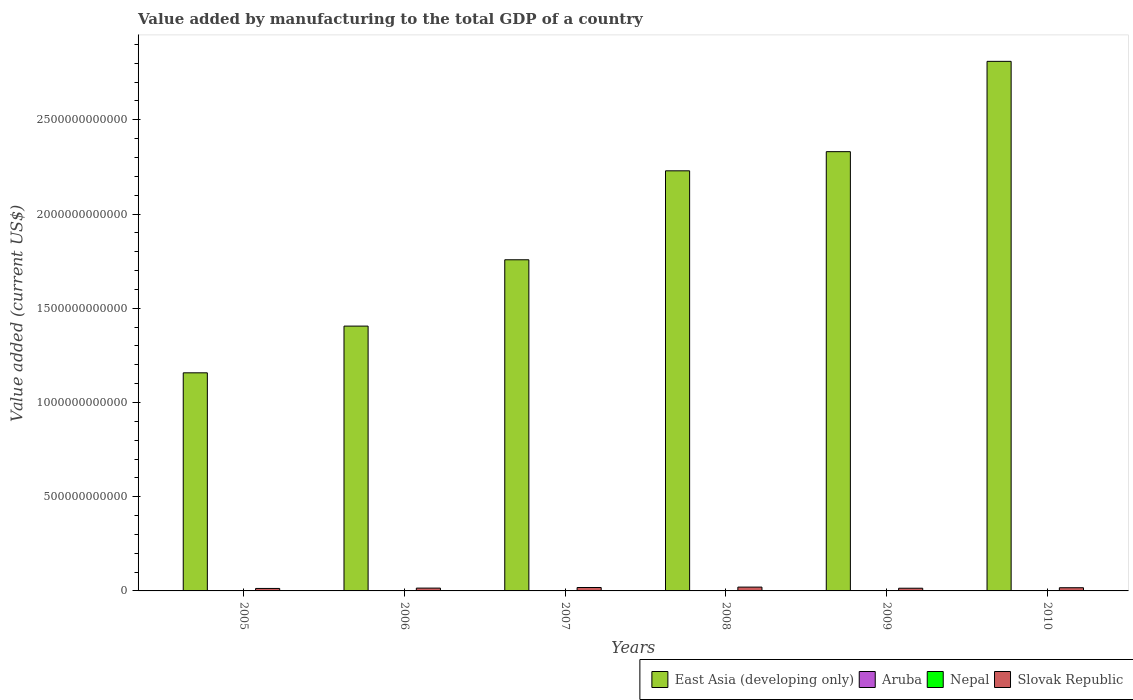How many different coloured bars are there?
Offer a terse response. 4. Are the number of bars per tick equal to the number of legend labels?
Keep it short and to the point. Yes. Are the number of bars on each tick of the X-axis equal?
Ensure brevity in your answer.  Yes. How many bars are there on the 4th tick from the left?
Make the answer very short. 4. What is the label of the 1st group of bars from the left?
Provide a short and direct response. 2005. In how many cases, is the number of bars for a given year not equal to the number of legend labels?
Make the answer very short. 0. What is the value added by manufacturing to the total GDP in Nepal in 2006?
Your answer should be compact. 6.61e+08. Across all years, what is the maximum value added by manufacturing to the total GDP in Aruba?
Keep it short and to the point. 1.02e+08. Across all years, what is the minimum value added by manufacturing to the total GDP in Slovak Republic?
Offer a very short reply. 1.31e+1. In which year was the value added by manufacturing to the total GDP in Aruba maximum?
Provide a short and direct response. 2009. What is the total value added by manufacturing to the total GDP in Nepal in the graph?
Offer a terse response. 4.70e+09. What is the difference between the value added by manufacturing to the total GDP in East Asia (developing only) in 2005 and that in 2006?
Offer a terse response. -2.48e+11. What is the difference between the value added by manufacturing to the total GDP in Aruba in 2005 and the value added by manufacturing to the total GDP in Nepal in 2006?
Keep it short and to the point. -5.75e+08. What is the average value added by manufacturing to the total GDP in Nepal per year?
Keep it short and to the point. 7.84e+08. In the year 2008, what is the difference between the value added by manufacturing to the total GDP in Aruba and value added by manufacturing to the total GDP in Nepal?
Provide a short and direct response. -7.78e+08. What is the ratio of the value added by manufacturing to the total GDP in Nepal in 2005 to that in 2010?
Provide a succinct answer. 0.65. Is the value added by manufacturing to the total GDP in Slovak Republic in 2007 less than that in 2010?
Provide a succinct answer. No. What is the difference between the highest and the second highest value added by manufacturing to the total GDP in Aruba?
Your answer should be compact. 3.30e+05. What is the difference between the highest and the lowest value added by manufacturing to the total GDP in East Asia (developing only)?
Give a very brief answer. 1.65e+12. Is the sum of the value added by manufacturing to the total GDP in East Asia (developing only) in 2009 and 2010 greater than the maximum value added by manufacturing to the total GDP in Slovak Republic across all years?
Offer a terse response. Yes. What does the 3rd bar from the left in 2008 represents?
Your answer should be very brief. Nepal. What does the 3rd bar from the right in 2010 represents?
Keep it short and to the point. Aruba. Is it the case that in every year, the sum of the value added by manufacturing to the total GDP in Slovak Republic and value added by manufacturing to the total GDP in East Asia (developing only) is greater than the value added by manufacturing to the total GDP in Nepal?
Your response must be concise. Yes. What is the difference between two consecutive major ticks on the Y-axis?
Make the answer very short. 5.00e+11. Are the values on the major ticks of Y-axis written in scientific E-notation?
Ensure brevity in your answer.  No. Does the graph contain grids?
Your answer should be very brief. No. Where does the legend appear in the graph?
Offer a very short reply. Bottom right. How are the legend labels stacked?
Provide a succinct answer. Horizontal. What is the title of the graph?
Your response must be concise. Value added by manufacturing to the total GDP of a country. Does "Nigeria" appear as one of the legend labels in the graph?
Provide a short and direct response. No. What is the label or title of the Y-axis?
Your response must be concise. Value added (current US$). What is the Value added (current US$) of East Asia (developing only) in 2005?
Your answer should be very brief. 1.16e+12. What is the Value added (current US$) of Aruba in 2005?
Provide a succinct answer. 8.62e+07. What is the Value added (current US$) of Nepal in 2005?
Ensure brevity in your answer.  6.19e+08. What is the Value added (current US$) in Slovak Republic in 2005?
Give a very brief answer. 1.31e+1. What is the Value added (current US$) in East Asia (developing only) in 2006?
Provide a succinct answer. 1.41e+12. What is the Value added (current US$) in Aruba in 2006?
Your response must be concise. 9.12e+07. What is the Value added (current US$) in Nepal in 2006?
Offer a very short reply. 6.61e+08. What is the Value added (current US$) in Slovak Republic in 2006?
Give a very brief answer. 1.49e+1. What is the Value added (current US$) of East Asia (developing only) in 2007?
Provide a short and direct response. 1.76e+12. What is the Value added (current US$) of Aruba in 2007?
Offer a terse response. 1.01e+08. What is the Value added (current US$) of Nepal in 2007?
Your answer should be very brief. 7.40e+08. What is the Value added (current US$) in Slovak Republic in 2007?
Ensure brevity in your answer.  1.81e+1. What is the Value added (current US$) in East Asia (developing only) in 2008?
Your response must be concise. 2.23e+12. What is the Value added (current US$) in Aruba in 2008?
Keep it short and to the point. 1.02e+08. What is the Value added (current US$) of Nepal in 2008?
Offer a very short reply. 8.80e+08. What is the Value added (current US$) of Slovak Republic in 2008?
Offer a terse response. 2.03e+1. What is the Value added (current US$) in East Asia (developing only) in 2009?
Provide a short and direct response. 2.33e+12. What is the Value added (current US$) of Aruba in 2009?
Keep it short and to the point. 1.02e+08. What is the Value added (current US$) in Nepal in 2009?
Make the answer very short. 8.51e+08. What is the Value added (current US$) of Slovak Republic in 2009?
Offer a very short reply. 1.43e+1. What is the Value added (current US$) of East Asia (developing only) in 2010?
Keep it short and to the point. 2.81e+12. What is the Value added (current US$) in Aruba in 2010?
Give a very brief answer. 1.01e+08. What is the Value added (current US$) of Nepal in 2010?
Keep it short and to the point. 9.52e+08. What is the Value added (current US$) of Slovak Republic in 2010?
Give a very brief answer. 1.69e+1. Across all years, what is the maximum Value added (current US$) in East Asia (developing only)?
Your answer should be compact. 2.81e+12. Across all years, what is the maximum Value added (current US$) of Aruba?
Your answer should be very brief. 1.02e+08. Across all years, what is the maximum Value added (current US$) in Nepal?
Provide a succinct answer. 9.52e+08. Across all years, what is the maximum Value added (current US$) in Slovak Republic?
Your answer should be compact. 2.03e+1. Across all years, what is the minimum Value added (current US$) in East Asia (developing only)?
Provide a succinct answer. 1.16e+12. Across all years, what is the minimum Value added (current US$) of Aruba?
Provide a short and direct response. 8.62e+07. Across all years, what is the minimum Value added (current US$) of Nepal?
Your answer should be very brief. 6.19e+08. Across all years, what is the minimum Value added (current US$) in Slovak Republic?
Offer a terse response. 1.31e+1. What is the total Value added (current US$) of East Asia (developing only) in the graph?
Make the answer very short. 1.17e+13. What is the total Value added (current US$) of Aruba in the graph?
Provide a succinct answer. 5.84e+08. What is the total Value added (current US$) of Nepal in the graph?
Give a very brief answer. 4.70e+09. What is the total Value added (current US$) of Slovak Republic in the graph?
Your response must be concise. 9.76e+1. What is the difference between the Value added (current US$) in East Asia (developing only) in 2005 and that in 2006?
Provide a short and direct response. -2.48e+11. What is the difference between the Value added (current US$) in Aruba in 2005 and that in 2006?
Your answer should be very brief. -4.98e+06. What is the difference between the Value added (current US$) of Nepal in 2005 and that in 2006?
Offer a very short reply. -4.23e+07. What is the difference between the Value added (current US$) of Slovak Republic in 2005 and that in 2006?
Offer a terse response. -1.83e+09. What is the difference between the Value added (current US$) of East Asia (developing only) in 2005 and that in 2007?
Make the answer very short. -6.00e+11. What is the difference between the Value added (current US$) in Aruba in 2005 and that in 2007?
Provide a short and direct response. -1.46e+07. What is the difference between the Value added (current US$) in Nepal in 2005 and that in 2007?
Your response must be concise. -1.21e+08. What is the difference between the Value added (current US$) in Slovak Republic in 2005 and that in 2007?
Your answer should be very brief. -5.00e+09. What is the difference between the Value added (current US$) in East Asia (developing only) in 2005 and that in 2008?
Offer a very short reply. -1.07e+12. What is the difference between the Value added (current US$) of Aruba in 2005 and that in 2008?
Provide a succinct answer. -1.57e+07. What is the difference between the Value added (current US$) of Nepal in 2005 and that in 2008?
Give a very brief answer. -2.60e+08. What is the difference between the Value added (current US$) in Slovak Republic in 2005 and that in 2008?
Give a very brief answer. -7.15e+09. What is the difference between the Value added (current US$) of East Asia (developing only) in 2005 and that in 2009?
Make the answer very short. -1.17e+12. What is the difference between the Value added (current US$) of Aruba in 2005 and that in 2009?
Give a very brief answer. -1.60e+07. What is the difference between the Value added (current US$) in Nepal in 2005 and that in 2009?
Make the answer very short. -2.32e+08. What is the difference between the Value added (current US$) in Slovak Republic in 2005 and that in 2009?
Ensure brevity in your answer.  -1.19e+09. What is the difference between the Value added (current US$) in East Asia (developing only) in 2005 and that in 2010?
Ensure brevity in your answer.  -1.65e+12. What is the difference between the Value added (current US$) of Aruba in 2005 and that in 2010?
Offer a terse response. -1.50e+07. What is the difference between the Value added (current US$) of Nepal in 2005 and that in 2010?
Keep it short and to the point. -3.32e+08. What is the difference between the Value added (current US$) of Slovak Republic in 2005 and that in 2010?
Your answer should be compact. -3.81e+09. What is the difference between the Value added (current US$) in East Asia (developing only) in 2006 and that in 2007?
Offer a very short reply. -3.52e+11. What is the difference between the Value added (current US$) of Aruba in 2006 and that in 2007?
Offer a terse response. -9.60e+06. What is the difference between the Value added (current US$) in Nepal in 2006 and that in 2007?
Make the answer very short. -7.87e+07. What is the difference between the Value added (current US$) of Slovak Republic in 2006 and that in 2007?
Offer a terse response. -3.17e+09. What is the difference between the Value added (current US$) in East Asia (developing only) in 2006 and that in 2008?
Your answer should be compact. -8.24e+11. What is the difference between the Value added (current US$) of Aruba in 2006 and that in 2008?
Your answer should be compact. -1.07e+07. What is the difference between the Value added (current US$) of Nepal in 2006 and that in 2008?
Offer a very short reply. -2.18e+08. What is the difference between the Value added (current US$) in Slovak Republic in 2006 and that in 2008?
Provide a short and direct response. -5.32e+09. What is the difference between the Value added (current US$) of East Asia (developing only) in 2006 and that in 2009?
Offer a terse response. -9.26e+11. What is the difference between the Value added (current US$) in Aruba in 2006 and that in 2009?
Make the answer very short. -1.10e+07. What is the difference between the Value added (current US$) in Nepal in 2006 and that in 2009?
Provide a short and direct response. -1.90e+08. What is the difference between the Value added (current US$) of Slovak Republic in 2006 and that in 2009?
Ensure brevity in your answer.  6.43e+08. What is the difference between the Value added (current US$) in East Asia (developing only) in 2006 and that in 2010?
Give a very brief answer. -1.40e+12. What is the difference between the Value added (current US$) in Aruba in 2006 and that in 2010?
Keep it short and to the point. -1.00e+07. What is the difference between the Value added (current US$) of Nepal in 2006 and that in 2010?
Keep it short and to the point. -2.90e+08. What is the difference between the Value added (current US$) in Slovak Republic in 2006 and that in 2010?
Make the answer very short. -1.97e+09. What is the difference between the Value added (current US$) of East Asia (developing only) in 2007 and that in 2008?
Offer a terse response. -4.72e+11. What is the difference between the Value added (current US$) of Aruba in 2007 and that in 2008?
Offer a terse response. -1.11e+06. What is the difference between the Value added (current US$) in Nepal in 2007 and that in 2008?
Your response must be concise. -1.39e+08. What is the difference between the Value added (current US$) of Slovak Republic in 2007 and that in 2008?
Your answer should be compact. -2.14e+09. What is the difference between the Value added (current US$) of East Asia (developing only) in 2007 and that in 2009?
Give a very brief answer. -5.74e+11. What is the difference between the Value added (current US$) in Aruba in 2007 and that in 2009?
Offer a very short reply. -1.44e+06. What is the difference between the Value added (current US$) in Nepal in 2007 and that in 2009?
Your response must be concise. -1.11e+08. What is the difference between the Value added (current US$) of Slovak Republic in 2007 and that in 2009?
Give a very brief answer. 3.81e+09. What is the difference between the Value added (current US$) in East Asia (developing only) in 2007 and that in 2010?
Ensure brevity in your answer.  -1.05e+12. What is the difference between the Value added (current US$) of Aruba in 2007 and that in 2010?
Your answer should be compact. -4.08e+05. What is the difference between the Value added (current US$) in Nepal in 2007 and that in 2010?
Provide a succinct answer. -2.11e+08. What is the difference between the Value added (current US$) of Slovak Republic in 2007 and that in 2010?
Make the answer very short. 1.20e+09. What is the difference between the Value added (current US$) of East Asia (developing only) in 2008 and that in 2009?
Offer a terse response. -1.02e+11. What is the difference between the Value added (current US$) in Aruba in 2008 and that in 2009?
Provide a short and direct response. -3.30e+05. What is the difference between the Value added (current US$) of Nepal in 2008 and that in 2009?
Provide a short and direct response. 2.82e+07. What is the difference between the Value added (current US$) of Slovak Republic in 2008 and that in 2009?
Give a very brief answer. 5.96e+09. What is the difference between the Value added (current US$) of East Asia (developing only) in 2008 and that in 2010?
Your response must be concise. -5.81e+11. What is the difference between the Value added (current US$) in Aruba in 2008 and that in 2010?
Offer a very short reply. 7.04e+05. What is the difference between the Value added (current US$) of Nepal in 2008 and that in 2010?
Provide a succinct answer. -7.20e+07. What is the difference between the Value added (current US$) in Slovak Republic in 2008 and that in 2010?
Keep it short and to the point. 3.34e+09. What is the difference between the Value added (current US$) in East Asia (developing only) in 2009 and that in 2010?
Provide a short and direct response. -4.79e+11. What is the difference between the Value added (current US$) in Aruba in 2009 and that in 2010?
Ensure brevity in your answer.  1.03e+06. What is the difference between the Value added (current US$) in Nepal in 2009 and that in 2010?
Offer a terse response. -1.00e+08. What is the difference between the Value added (current US$) in Slovak Republic in 2009 and that in 2010?
Provide a succinct answer. -2.62e+09. What is the difference between the Value added (current US$) in East Asia (developing only) in 2005 and the Value added (current US$) in Aruba in 2006?
Your answer should be very brief. 1.16e+12. What is the difference between the Value added (current US$) in East Asia (developing only) in 2005 and the Value added (current US$) in Nepal in 2006?
Provide a short and direct response. 1.16e+12. What is the difference between the Value added (current US$) of East Asia (developing only) in 2005 and the Value added (current US$) of Slovak Republic in 2006?
Offer a terse response. 1.14e+12. What is the difference between the Value added (current US$) in Aruba in 2005 and the Value added (current US$) in Nepal in 2006?
Ensure brevity in your answer.  -5.75e+08. What is the difference between the Value added (current US$) of Aruba in 2005 and the Value added (current US$) of Slovak Republic in 2006?
Offer a very short reply. -1.49e+1. What is the difference between the Value added (current US$) of Nepal in 2005 and the Value added (current US$) of Slovak Republic in 2006?
Give a very brief answer. -1.43e+1. What is the difference between the Value added (current US$) of East Asia (developing only) in 2005 and the Value added (current US$) of Aruba in 2007?
Make the answer very short. 1.16e+12. What is the difference between the Value added (current US$) in East Asia (developing only) in 2005 and the Value added (current US$) in Nepal in 2007?
Your answer should be very brief. 1.16e+12. What is the difference between the Value added (current US$) in East Asia (developing only) in 2005 and the Value added (current US$) in Slovak Republic in 2007?
Your answer should be compact. 1.14e+12. What is the difference between the Value added (current US$) in Aruba in 2005 and the Value added (current US$) in Nepal in 2007?
Ensure brevity in your answer.  -6.54e+08. What is the difference between the Value added (current US$) of Aruba in 2005 and the Value added (current US$) of Slovak Republic in 2007?
Offer a terse response. -1.80e+1. What is the difference between the Value added (current US$) of Nepal in 2005 and the Value added (current US$) of Slovak Republic in 2007?
Make the answer very short. -1.75e+1. What is the difference between the Value added (current US$) in East Asia (developing only) in 2005 and the Value added (current US$) in Aruba in 2008?
Offer a very short reply. 1.16e+12. What is the difference between the Value added (current US$) of East Asia (developing only) in 2005 and the Value added (current US$) of Nepal in 2008?
Your answer should be compact. 1.16e+12. What is the difference between the Value added (current US$) in East Asia (developing only) in 2005 and the Value added (current US$) in Slovak Republic in 2008?
Make the answer very short. 1.14e+12. What is the difference between the Value added (current US$) of Aruba in 2005 and the Value added (current US$) of Nepal in 2008?
Ensure brevity in your answer.  -7.93e+08. What is the difference between the Value added (current US$) in Aruba in 2005 and the Value added (current US$) in Slovak Republic in 2008?
Your response must be concise. -2.02e+1. What is the difference between the Value added (current US$) in Nepal in 2005 and the Value added (current US$) in Slovak Republic in 2008?
Give a very brief answer. -1.96e+1. What is the difference between the Value added (current US$) in East Asia (developing only) in 2005 and the Value added (current US$) in Aruba in 2009?
Your answer should be very brief. 1.16e+12. What is the difference between the Value added (current US$) of East Asia (developing only) in 2005 and the Value added (current US$) of Nepal in 2009?
Keep it short and to the point. 1.16e+12. What is the difference between the Value added (current US$) in East Asia (developing only) in 2005 and the Value added (current US$) in Slovak Republic in 2009?
Your response must be concise. 1.14e+12. What is the difference between the Value added (current US$) in Aruba in 2005 and the Value added (current US$) in Nepal in 2009?
Provide a short and direct response. -7.65e+08. What is the difference between the Value added (current US$) of Aruba in 2005 and the Value added (current US$) of Slovak Republic in 2009?
Provide a short and direct response. -1.42e+1. What is the difference between the Value added (current US$) of Nepal in 2005 and the Value added (current US$) of Slovak Republic in 2009?
Give a very brief answer. -1.37e+1. What is the difference between the Value added (current US$) of East Asia (developing only) in 2005 and the Value added (current US$) of Aruba in 2010?
Offer a terse response. 1.16e+12. What is the difference between the Value added (current US$) of East Asia (developing only) in 2005 and the Value added (current US$) of Nepal in 2010?
Offer a very short reply. 1.16e+12. What is the difference between the Value added (current US$) in East Asia (developing only) in 2005 and the Value added (current US$) in Slovak Republic in 2010?
Give a very brief answer. 1.14e+12. What is the difference between the Value added (current US$) in Aruba in 2005 and the Value added (current US$) in Nepal in 2010?
Your answer should be very brief. -8.65e+08. What is the difference between the Value added (current US$) in Aruba in 2005 and the Value added (current US$) in Slovak Republic in 2010?
Make the answer very short. -1.68e+1. What is the difference between the Value added (current US$) of Nepal in 2005 and the Value added (current US$) of Slovak Republic in 2010?
Your answer should be compact. -1.63e+1. What is the difference between the Value added (current US$) in East Asia (developing only) in 2006 and the Value added (current US$) in Aruba in 2007?
Provide a short and direct response. 1.41e+12. What is the difference between the Value added (current US$) in East Asia (developing only) in 2006 and the Value added (current US$) in Nepal in 2007?
Your response must be concise. 1.40e+12. What is the difference between the Value added (current US$) in East Asia (developing only) in 2006 and the Value added (current US$) in Slovak Republic in 2007?
Your answer should be compact. 1.39e+12. What is the difference between the Value added (current US$) of Aruba in 2006 and the Value added (current US$) of Nepal in 2007?
Make the answer very short. -6.49e+08. What is the difference between the Value added (current US$) in Aruba in 2006 and the Value added (current US$) in Slovak Republic in 2007?
Offer a very short reply. -1.80e+1. What is the difference between the Value added (current US$) of Nepal in 2006 and the Value added (current US$) of Slovak Republic in 2007?
Ensure brevity in your answer.  -1.74e+1. What is the difference between the Value added (current US$) of East Asia (developing only) in 2006 and the Value added (current US$) of Aruba in 2008?
Give a very brief answer. 1.41e+12. What is the difference between the Value added (current US$) of East Asia (developing only) in 2006 and the Value added (current US$) of Nepal in 2008?
Make the answer very short. 1.40e+12. What is the difference between the Value added (current US$) of East Asia (developing only) in 2006 and the Value added (current US$) of Slovak Republic in 2008?
Keep it short and to the point. 1.39e+12. What is the difference between the Value added (current US$) in Aruba in 2006 and the Value added (current US$) in Nepal in 2008?
Provide a succinct answer. -7.88e+08. What is the difference between the Value added (current US$) of Aruba in 2006 and the Value added (current US$) of Slovak Republic in 2008?
Make the answer very short. -2.02e+1. What is the difference between the Value added (current US$) in Nepal in 2006 and the Value added (current US$) in Slovak Republic in 2008?
Provide a succinct answer. -1.96e+1. What is the difference between the Value added (current US$) of East Asia (developing only) in 2006 and the Value added (current US$) of Aruba in 2009?
Give a very brief answer. 1.41e+12. What is the difference between the Value added (current US$) of East Asia (developing only) in 2006 and the Value added (current US$) of Nepal in 2009?
Your answer should be compact. 1.40e+12. What is the difference between the Value added (current US$) of East Asia (developing only) in 2006 and the Value added (current US$) of Slovak Republic in 2009?
Provide a short and direct response. 1.39e+12. What is the difference between the Value added (current US$) in Aruba in 2006 and the Value added (current US$) in Nepal in 2009?
Keep it short and to the point. -7.60e+08. What is the difference between the Value added (current US$) of Aruba in 2006 and the Value added (current US$) of Slovak Republic in 2009?
Your response must be concise. -1.42e+1. What is the difference between the Value added (current US$) in Nepal in 2006 and the Value added (current US$) in Slovak Republic in 2009?
Your answer should be compact. -1.36e+1. What is the difference between the Value added (current US$) in East Asia (developing only) in 2006 and the Value added (current US$) in Aruba in 2010?
Your answer should be very brief. 1.41e+12. What is the difference between the Value added (current US$) of East Asia (developing only) in 2006 and the Value added (current US$) of Nepal in 2010?
Your response must be concise. 1.40e+12. What is the difference between the Value added (current US$) in East Asia (developing only) in 2006 and the Value added (current US$) in Slovak Republic in 2010?
Your response must be concise. 1.39e+12. What is the difference between the Value added (current US$) of Aruba in 2006 and the Value added (current US$) of Nepal in 2010?
Offer a terse response. -8.60e+08. What is the difference between the Value added (current US$) in Aruba in 2006 and the Value added (current US$) in Slovak Republic in 2010?
Your answer should be very brief. -1.68e+1. What is the difference between the Value added (current US$) of Nepal in 2006 and the Value added (current US$) of Slovak Republic in 2010?
Provide a succinct answer. -1.63e+1. What is the difference between the Value added (current US$) in East Asia (developing only) in 2007 and the Value added (current US$) in Aruba in 2008?
Your response must be concise. 1.76e+12. What is the difference between the Value added (current US$) in East Asia (developing only) in 2007 and the Value added (current US$) in Nepal in 2008?
Make the answer very short. 1.76e+12. What is the difference between the Value added (current US$) of East Asia (developing only) in 2007 and the Value added (current US$) of Slovak Republic in 2008?
Your answer should be compact. 1.74e+12. What is the difference between the Value added (current US$) of Aruba in 2007 and the Value added (current US$) of Nepal in 2008?
Provide a short and direct response. -7.79e+08. What is the difference between the Value added (current US$) of Aruba in 2007 and the Value added (current US$) of Slovak Republic in 2008?
Your answer should be compact. -2.02e+1. What is the difference between the Value added (current US$) in Nepal in 2007 and the Value added (current US$) in Slovak Republic in 2008?
Offer a very short reply. -1.95e+1. What is the difference between the Value added (current US$) of East Asia (developing only) in 2007 and the Value added (current US$) of Aruba in 2009?
Provide a short and direct response. 1.76e+12. What is the difference between the Value added (current US$) in East Asia (developing only) in 2007 and the Value added (current US$) in Nepal in 2009?
Your answer should be compact. 1.76e+12. What is the difference between the Value added (current US$) in East Asia (developing only) in 2007 and the Value added (current US$) in Slovak Republic in 2009?
Offer a terse response. 1.74e+12. What is the difference between the Value added (current US$) in Aruba in 2007 and the Value added (current US$) in Nepal in 2009?
Provide a succinct answer. -7.51e+08. What is the difference between the Value added (current US$) in Aruba in 2007 and the Value added (current US$) in Slovak Republic in 2009?
Offer a terse response. -1.42e+1. What is the difference between the Value added (current US$) in Nepal in 2007 and the Value added (current US$) in Slovak Republic in 2009?
Your answer should be very brief. -1.36e+1. What is the difference between the Value added (current US$) in East Asia (developing only) in 2007 and the Value added (current US$) in Aruba in 2010?
Offer a terse response. 1.76e+12. What is the difference between the Value added (current US$) in East Asia (developing only) in 2007 and the Value added (current US$) in Nepal in 2010?
Provide a short and direct response. 1.76e+12. What is the difference between the Value added (current US$) of East Asia (developing only) in 2007 and the Value added (current US$) of Slovak Republic in 2010?
Your answer should be very brief. 1.74e+12. What is the difference between the Value added (current US$) of Aruba in 2007 and the Value added (current US$) of Nepal in 2010?
Provide a short and direct response. -8.51e+08. What is the difference between the Value added (current US$) of Aruba in 2007 and the Value added (current US$) of Slovak Republic in 2010?
Give a very brief answer. -1.68e+1. What is the difference between the Value added (current US$) of Nepal in 2007 and the Value added (current US$) of Slovak Republic in 2010?
Give a very brief answer. -1.62e+1. What is the difference between the Value added (current US$) of East Asia (developing only) in 2008 and the Value added (current US$) of Aruba in 2009?
Your answer should be compact. 2.23e+12. What is the difference between the Value added (current US$) in East Asia (developing only) in 2008 and the Value added (current US$) in Nepal in 2009?
Keep it short and to the point. 2.23e+12. What is the difference between the Value added (current US$) of East Asia (developing only) in 2008 and the Value added (current US$) of Slovak Republic in 2009?
Keep it short and to the point. 2.22e+12. What is the difference between the Value added (current US$) in Aruba in 2008 and the Value added (current US$) in Nepal in 2009?
Offer a very short reply. -7.49e+08. What is the difference between the Value added (current US$) of Aruba in 2008 and the Value added (current US$) of Slovak Republic in 2009?
Provide a succinct answer. -1.42e+1. What is the difference between the Value added (current US$) in Nepal in 2008 and the Value added (current US$) in Slovak Republic in 2009?
Offer a very short reply. -1.34e+1. What is the difference between the Value added (current US$) of East Asia (developing only) in 2008 and the Value added (current US$) of Aruba in 2010?
Keep it short and to the point. 2.23e+12. What is the difference between the Value added (current US$) in East Asia (developing only) in 2008 and the Value added (current US$) in Nepal in 2010?
Your answer should be very brief. 2.23e+12. What is the difference between the Value added (current US$) of East Asia (developing only) in 2008 and the Value added (current US$) of Slovak Republic in 2010?
Make the answer very short. 2.21e+12. What is the difference between the Value added (current US$) of Aruba in 2008 and the Value added (current US$) of Nepal in 2010?
Your response must be concise. -8.50e+08. What is the difference between the Value added (current US$) of Aruba in 2008 and the Value added (current US$) of Slovak Republic in 2010?
Your answer should be very brief. -1.68e+1. What is the difference between the Value added (current US$) of Nepal in 2008 and the Value added (current US$) of Slovak Republic in 2010?
Your answer should be compact. -1.60e+1. What is the difference between the Value added (current US$) of East Asia (developing only) in 2009 and the Value added (current US$) of Aruba in 2010?
Provide a succinct answer. 2.33e+12. What is the difference between the Value added (current US$) in East Asia (developing only) in 2009 and the Value added (current US$) in Nepal in 2010?
Ensure brevity in your answer.  2.33e+12. What is the difference between the Value added (current US$) in East Asia (developing only) in 2009 and the Value added (current US$) in Slovak Republic in 2010?
Offer a very short reply. 2.31e+12. What is the difference between the Value added (current US$) of Aruba in 2009 and the Value added (current US$) of Nepal in 2010?
Give a very brief answer. -8.49e+08. What is the difference between the Value added (current US$) of Aruba in 2009 and the Value added (current US$) of Slovak Republic in 2010?
Provide a succinct answer. -1.68e+1. What is the difference between the Value added (current US$) of Nepal in 2009 and the Value added (current US$) of Slovak Republic in 2010?
Provide a succinct answer. -1.61e+1. What is the average Value added (current US$) of East Asia (developing only) per year?
Ensure brevity in your answer.  1.95e+12. What is the average Value added (current US$) in Aruba per year?
Provide a short and direct response. 9.73e+07. What is the average Value added (current US$) of Nepal per year?
Provide a short and direct response. 7.84e+08. What is the average Value added (current US$) of Slovak Republic per year?
Your response must be concise. 1.63e+1. In the year 2005, what is the difference between the Value added (current US$) in East Asia (developing only) and Value added (current US$) in Aruba?
Ensure brevity in your answer.  1.16e+12. In the year 2005, what is the difference between the Value added (current US$) in East Asia (developing only) and Value added (current US$) in Nepal?
Provide a short and direct response. 1.16e+12. In the year 2005, what is the difference between the Value added (current US$) in East Asia (developing only) and Value added (current US$) in Slovak Republic?
Offer a terse response. 1.14e+12. In the year 2005, what is the difference between the Value added (current US$) of Aruba and Value added (current US$) of Nepal?
Provide a succinct answer. -5.33e+08. In the year 2005, what is the difference between the Value added (current US$) of Aruba and Value added (current US$) of Slovak Republic?
Ensure brevity in your answer.  -1.30e+1. In the year 2005, what is the difference between the Value added (current US$) of Nepal and Value added (current US$) of Slovak Republic?
Make the answer very short. -1.25e+1. In the year 2006, what is the difference between the Value added (current US$) in East Asia (developing only) and Value added (current US$) in Aruba?
Ensure brevity in your answer.  1.41e+12. In the year 2006, what is the difference between the Value added (current US$) of East Asia (developing only) and Value added (current US$) of Nepal?
Ensure brevity in your answer.  1.40e+12. In the year 2006, what is the difference between the Value added (current US$) in East Asia (developing only) and Value added (current US$) in Slovak Republic?
Give a very brief answer. 1.39e+12. In the year 2006, what is the difference between the Value added (current US$) in Aruba and Value added (current US$) in Nepal?
Keep it short and to the point. -5.70e+08. In the year 2006, what is the difference between the Value added (current US$) of Aruba and Value added (current US$) of Slovak Republic?
Offer a terse response. -1.48e+1. In the year 2006, what is the difference between the Value added (current US$) of Nepal and Value added (current US$) of Slovak Republic?
Offer a terse response. -1.43e+1. In the year 2007, what is the difference between the Value added (current US$) in East Asia (developing only) and Value added (current US$) in Aruba?
Your answer should be compact. 1.76e+12. In the year 2007, what is the difference between the Value added (current US$) of East Asia (developing only) and Value added (current US$) of Nepal?
Make the answer very short. 1.76e+12. In the year 2007, what is the difference between the Value added (current US$) in East Asia (developing only) and Value added (current US$) in Slovak Republic?
Provide a succinct answer. 1.74e+12. In the year 2007, what is the difference between the Value added (current US$) in Aruba and Value added (current US$) in Nepal?
Give a very brief answer. -6.39e+08. In the year 2007, what is the difference between the Value added (current US$) in Aruba and Value added (current US$) in Slovak Republic?
Provide a short and direct response. -1.80e+1. In the year 2007, what is the difference between the Value added (current US$) of Nepal and Value added (current US$) of Slovak Republic?
Provide a short and direct response. -1.74e+1. In the year 2008, what is the difference between the Value added (current US$) of East Asia (developing only) and Value added (current US$) of Aruba?
Your answer should be very brief. 2.23e+12. In the year 2008, what is the difference between the Value added (current US$) in East Asia (developing only) and Value added (current US$) in Nepal?
Offer a very short reply. 2.23e+12. In the year 2008, what is the difference between the Value added (current US$) of East Asia (developing only) and Value added (current US$) of Slovak Republic?
Offer a terse response. 2.21e+12. In the year 2008, what is the difference between the Value added (current US$) of Aruba and Value added (current US$) of Nepal?
Make the answer very short. -7.78e+08. In the year 2008, what is the difference between the Value added (current US$) of Aruba and Value added (current US$) of Slovak Republic?
Your answer should be compact. -2.02e+1. In the year 2008, what is the difference between the Value added (current US$) of Nepal and Value added (current US$) of Slovak Republic?
Give a very brief answer. -1.94e+1. In the year 2009, what is the difference between the Value added (current US$) in East Asia (developing only) and Value added (current US$) in Aruba?
Keep it short and to the point. 2.33e+12. In the year 2009, what is the difference between the Value added (current US$) in East Asia (developing only) and Value added (current US$) in Nepal?
Your answer should be compact. 2.33e+12. In the year 2009, what is the difference between the Value added (current US$) in East Asia (developing only) and Value added (current US$) in Slovak Republic?
Keep it short and to the point. 2.32e+12. In the year 2009, what is the difference between the Value added (current US$) of Aruba and Value added (current US$) of Nepal?
Make the answer very short. -7.49e+08. In the year 2009, what is the difference between the Value added (current US$) in Aruba and Value added (current US$) in Slovak Republic?
Provide a short and direct response. -1.42e+1. In the year 2009, what is the difference between the Value added (current US$) in Nepal and Value added (current US$) in Slovak Republic?
Your response must be concise. -1.34e+1. In the year 2010, what is the difference between the Value added (current US$) in East Asia (developing only) and Value added (current US$) in Aruba?
Your answer should be compact. 2.81e+12. In the year 2010, what is the difference between the Value added (current US$) of East Asia (developing only) and Value added (current US$) of Nepal?
Provide a short and direct response. 2.81e+12. In the year 2010, what is the difference between the Value added (current US$) in East Asia (developing only) and Value added (current US$) in Slovak Republic?
Your response must be concise. 2.79e+12. In the year 2010, what is the difference between the Value added (current US$) in Aruba and Value added (current US$) in Nepal?
Give a very brief answer. -8.50e+08. In the year 2010, what is the difference between the Value added (current US$) in Aruba and Value added (current US$) in Slovak Republic?
Your response must be concise. -1.68e+1. In the year 2010, what is the difference between the Value added (current US$) of Nepal and Value added (current US$) of Slovak Republic?
Provide a short and direct response. -1.60e+1. What is the ratio of the Value added (current US$) in East Asia (developing only) in 2005 to that in 2006?
Your answer should be very brief. 0.82. What is the ratio of the Value added (current US$) in Aruba in 2005 to that in 2006?
Make the answer very short. 0.95. What is the ratio of the Value added (current US$) in Nepal in 2005 to that in 2006?
Make the answer very short. 0.94. What is the ratio of the Value added (current US$) in Slovak Republic in 2005 to that in 2006?
Make the answer very short. 0.88. What is the ratio of the Value added (current US$) of East Asia (developing only) in 2005 to that in 2007?
Your response must be concise. 0.66. What is the ratio of the Value added (current US$) in Aruba in 2005 to that in 2007?
Offer a terse response. 0.86. What is the ratio of the Value added (current US$) of Nepal in 2005 to that in 2007?
Provide a short and direct response. 0.84. What is the ratio of the Value added (current US$) in Slovak Republic in 2005 to that in 2007?
Your answer should be compact. 0.72. What is the ratio of the Value added (current US$) of East Asia (developing only) in 2005 to that in 2008?
Make the answer very short. 0.52. What is the ratio of the Value added (current US$) of Aruba in 2005 to that in 2008?
Your response must be concise. 0.85. What is the ratio of the Value added (current US$) of Nepal in 2005 to that in 2008?
Keep it short and to the point. 0.7. What is the ratio of the Value added (current US$) of Slovak Republic in 2005 to that in 2008?
Provide a succinct answer. 0.65. What is the ratio of the Value added (current US$) in East Asia (developing only) in 2005 to that in 2009?
Make the answer very short. 0.5. What is the ratio of the Value added (current US$) of Aruba in 2005 to that in 2009?
Keep it short and to the point. 0.84. What is the ratio of the Value added (current US$) in Nepal in 2005 to that in 2009?
Make the answer very short. 0.73. What is the ratio of the Value added (current US$) of Slovak Republic in 2005 to that in 2009?
Your answer should be compact. 0.92. What is the ratio of the Value added (current US$) in East Asia (developing only) in 2005 to that in 2010?
Offer a very short reply. 0.41. What is the ratio of the Value added (current US$) of Aruba in 2005 to that in 2010?
Provide a succinct answer. 0.85. What is the ratio of the Value added (current US$) in Nepal in 2005 to that in 2010?
Your answer should be very brief. 0.65. What is the ratio of the Value added (current US$) of Slovak Republic in 2005 to that in 2010?
Your answer should be very brief. 0.78. What is the ratio of the Value added (current US$) of East Asia (developing only) in 2006 to that in 2007?
Provide a short and direct response. 0.8. What is the ratio of the Value added (current US$) in Aruba in 2006 to that in 2007?
Your answer should be very brief. 0.9. What is the ratio of the Value added (current US$) of Nepal in 2006 to that in 2007?
Your response must be concise. 0.89. What is the ratio of the Value added (current US$) of Slovak Republic in 2006 to that in 2007?
Ensure brevity in your answer.  0.82. What is the ratio of the Value added (current US$) in East Asia (developing only) in 2006 to that in 2008?
Give a very brief answer. 0.63. What is the ratio of the Value added (current US$) in Aruba in 2006 to that in 2008?
Ensure brevity in your answer.  0.89. What is the ratio of the Value added (current US$) in Nepal in 2006 to that in 2008?
Your answer should be compact. 0.75. What is the ratio of the Value added (current US$) of Slovak Republic in 2006 to that in 2008?
Your answer should be compact. 0.74. What is the ratio of the Value added (current US$) in East Asia (developing only) in 2006 to that in 2009?
Offer a very short reply. 0.6. What is the ratio of the Value added (current US$) of Aruba in 2006 to that in 2009?
Offer a very short reply. 0.89. What is the ratio of the Value added (current US$) in Nepal in 2006 to that in 2009?
Give a very brief answer. 0.78. What is the ratio of the Value added (current US$) in Slovak Republic in 2006 to that in 2009?
Provide a short and direct response. 1.04. What is the ratio of the Value added (current US$) of East Asia (developing only) in 2006 to that in 2010?
Make the answer very short. 0.5. What is the ratio of the Value added (current US$) of Aruba in 2006 to that in 2010?
Your response must be concise. 0.9. What is the ratio of the Value added (current US$) of Nepal in 2006 to that in 2010?
Keep it short and to the point. 0.7. What is the ratio of the Value added (current US$) in Slovak Republic in 2006 to that in 2010?
Your answer should be very brief. 0.88. What is the ratio of the Value added (current US$) in East Asia (developing only) in 2007 to that in 2008?
Offer a very short reply. 0.79. What is the ratio of the Value added (current US$) of Aruba in 2007 to that in 2008?
Your answer should be compact. 0.99. What is the ratio of the Value added (current US$) in Nepal in 2007 to that in 2008?
Offer a very short reply. 0.84. What is the ratio of the Value added (current US$) in Slovak Republic in 2007 to that in 2008?
Provide a short and direct response. 0.89. What is the ratio of the Value added (current US$) in East Asia (developing only) in 2007 to that in 2009?
Give a very brief answer. 0.75. What is the ratio of the Value added (current US$) in Aruba in 2007 to that in 2009?
Offer a terse response. 0.99. What is the ratio of the Value added (current US$) of Nepal in 2007 to that in 2009?
Your answer should be compact. 0.87. What is the ratio of the Value added (current US$) of Slovak Republic in 2007 to that in 2009?
Your answer should be very brief. 1.27. What is the ratio of the Value added (current US$) of East Asia (developing only) in 2007 to that in 2010?
Provide a succinct answer. 0.63. What is the ratio of the Value added (current US$) in Aruba in 2007 to that in 2010?
Make the answer very short. 1. What is the ratio of the Value added (current US$) of Nepal in 2007 to that in 2010?
Offer a very short reply. 0.78. What is the ratio of the Value added (current US$) in Slovak Republic in 2007 to that in 2010?
Your answer should be very brief. 1.07. What is the ratio of the Value added (current US$) in East Asia (developing only) in 2008 to that in 2009?
Ensure brevity in your answer.  0.96. What is the ratio of the Value added (current US$) of Aruba in 2008 to that in 2009?
Keep it short and to the point. 1. What is the ratio of the Value added (current US$) in Nepal in 2008 to that in 2009?
Provide a succinct answer. 1.03. What is the ratio of the Value added (current US$) of Slovak Republic in 2008 to that in 2009?
Your answer should be compact. 1.42. What is the ratio of the Value added (current US$) in East Asia (developing only) in 2008 to that in 2010?
Provide a succinct answer. 0.79. What is the ratio of the Value added (current US$) in Nepal in 2008 to that in 2010?
Your answer should be compact. 0.92. What is the ratio of the Value added (current US$) in Slovak Republic in 2008 to that in 2010?
Keep it short and to the point. 1.2. What is the ratio of the Value added (current US$) of East Asia (developing only) in 2009 to that in 2010?
Give a very brief answer. 0.83. What is the ratio of the Value added (current US$) of Aruba in 2009 to that in 2010?
Offer a terse response. 1.01. What is the ratio of the Value added (current US$) of Nepal in 2009 to that in 2010?
Offer a terse response. 0.89. What is the ratio of the Value added (current US$) of Slovak Republic in 2009 to that in 2010?
Ensure brevity in your answer.  0.85. What is the difference between the highest and the second highest Value added (current US$) of East Asia (developing only)?
Your response must be concise. 4.79e+11. What is the difference between the highest and the second highest Value added (current US$) in Aruba?
Provide a succinct answer. 3.30e+05. What is the difference between the highest and the second highest Value added (current US$) of Nepal?
Provide a succinct answer. 7.20e+07. What is the difference between the highest and the second highest Value added (current US$) of Slovak Republic?
Offer a terse response. 2.14e+09. What is the difference between the highest and the lowest Value added (current US$) of East Asia (developing only)?
Offer a very short reply. 1.65e+12. What is the difference between the highest and the lowest Value added (current US$) in Aruba?
Your response must be concise. 1.60e+07. What is the difference between the highest and the lowest Value added (current US$) of Nepal?
Keep it short and to the point. 3.32e+08. What is the difference between the highest and the lowest Value added (current US$) of Slovak Republic?
Ensure brevity in your answer.  7.15e+09. 